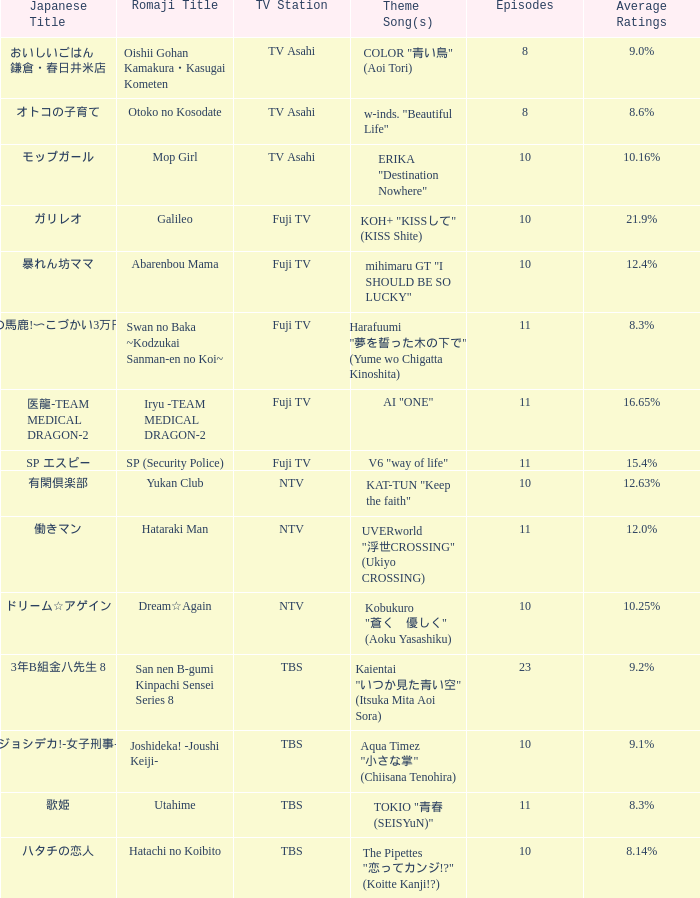What is the Theme Song of the Yukan Club? KAT-TUN "Keep the faith". 